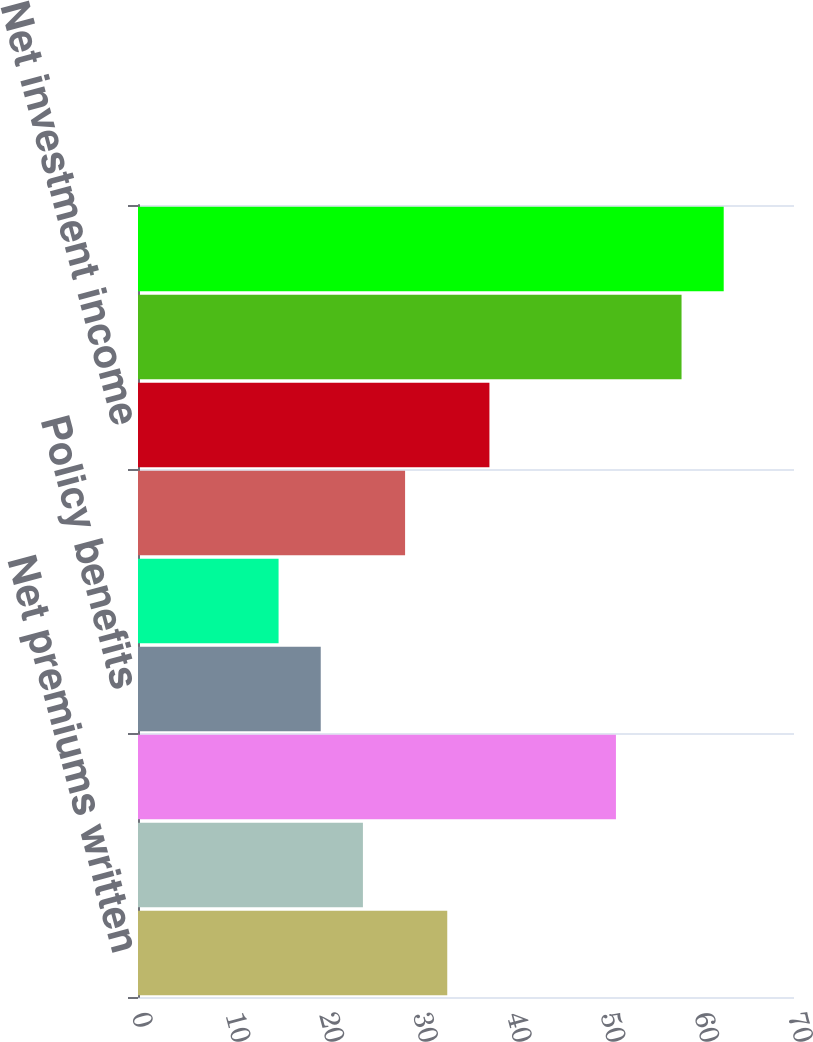Convert chart. <chart><loc_0><loc_0><loc_500><loc_500><bar_chart><fcel>Net premiums written<fcel>Net premiums earned<fcel>Losses and loss expenses<fcel>Policy benefits<fcel>Policy acquisition costs<fcel>Administrative expenses<fcel>Net investment income<fcel>Life underwriting income<fcel>Income tax expense<nl><fcel>33<fcel>24<fcel>51<fcel>19.5<fcel>15<fcel>28.5<fcel>37.5<fcel>58<fcel>62.5<nl></chart> 